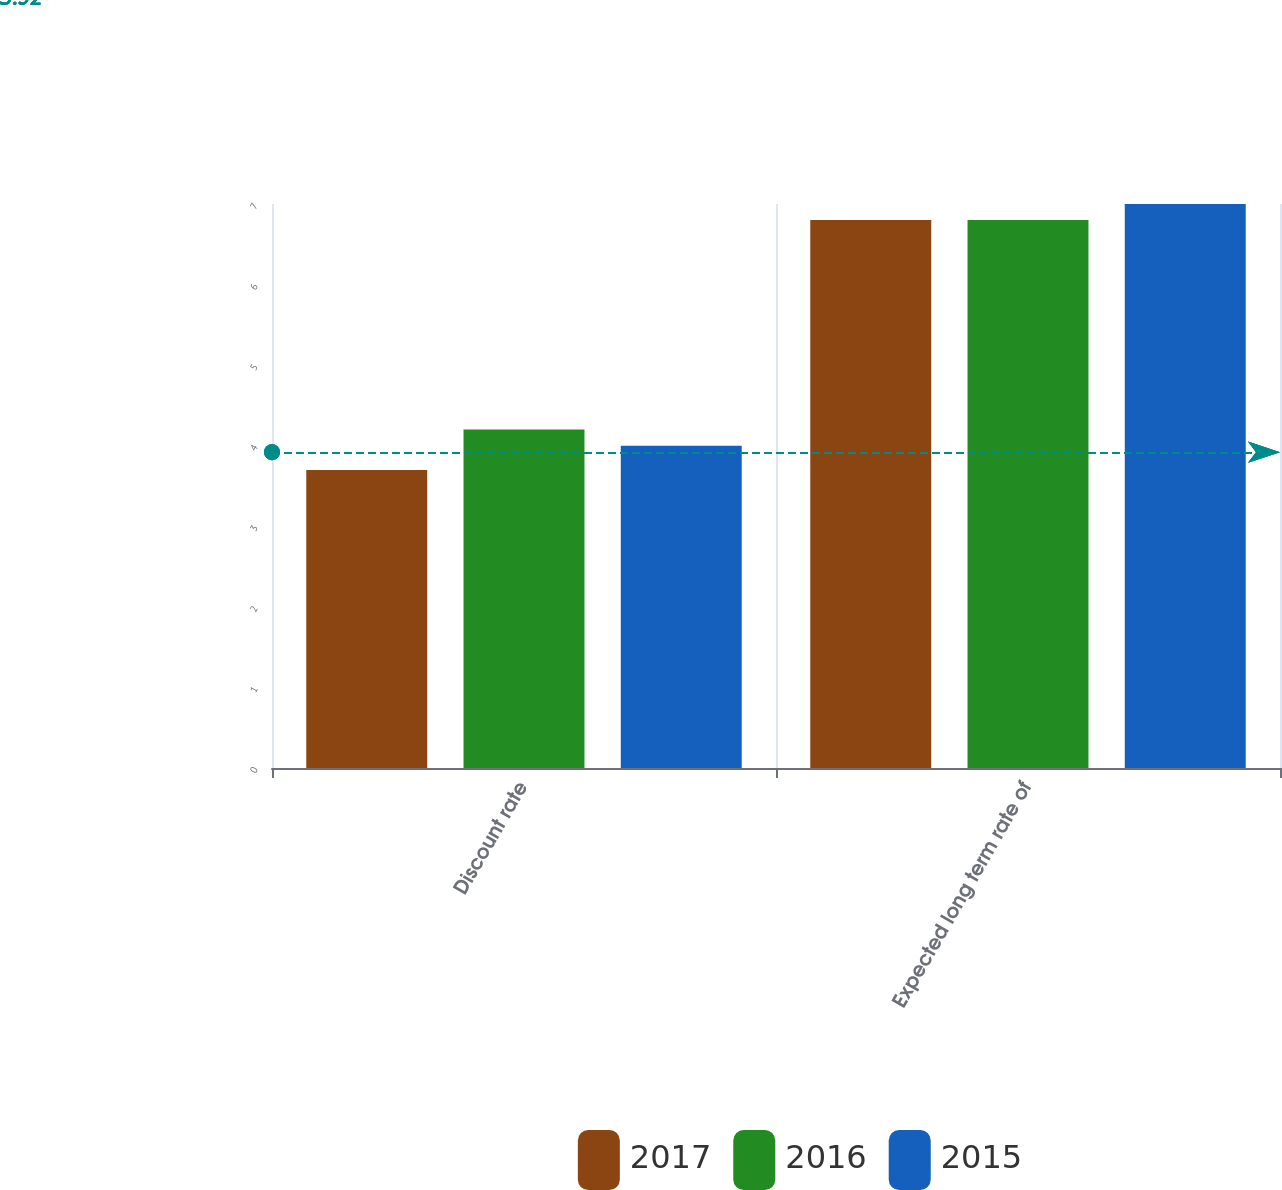<chart> <loc_0><loc_0><loc_500><loc_500><stacked_bar_chart><ecel><fcel>Discount rate<fcel>Expected long term rate of<nl><fcel>2017<fcel>3.7<fcel>6.8<nl><fcel>2016<fcel>4.2<fcel>6.8<nl><fcel>2015<fcel>4<fcel>7<nl></chart> 